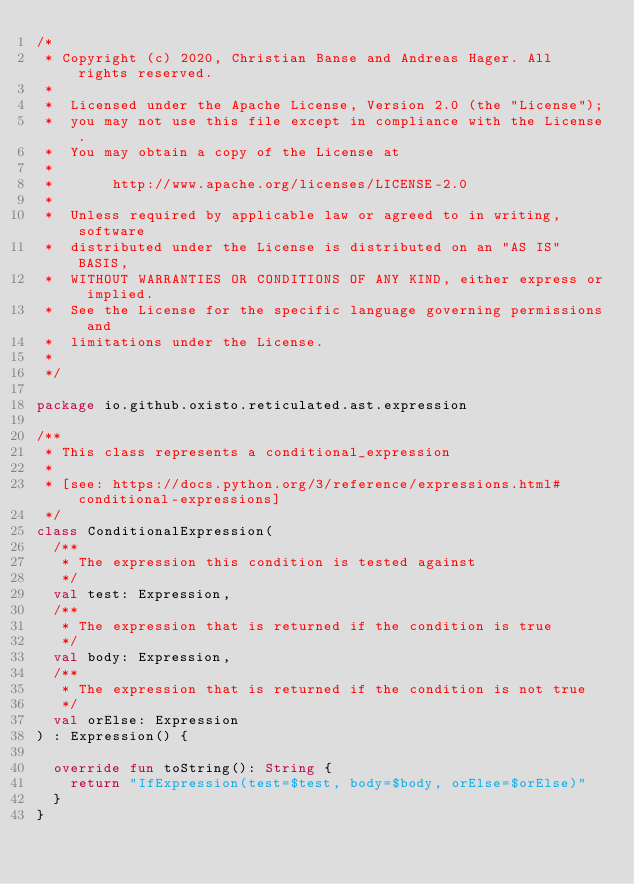<code> <loc_0><loc_0><loc_500><loc_500><_Kotlin_>/*
 * Copyright (c) 2020, Christian Banse and Andreas Hager. All rights reserved.
 *
 *  Licensed under the Apache License, Version 2.0 (the "License");
 *  you may not use this file except in compliance with the License.
 *  You may obtain a copy of the License at
 *
 *       http://www.apache.org/licenses/LICENSE-2.0
 *
 *  Unless required by applicable law or agreed to in writing, software
 *  distributed under the License is distributed on an "AS IS" BASIS,
 *  WITHOUT WARRANTIES OR CONDITIONS OF ANY KIND, either express or implied.
 *  See the License for the specific language governing permissions and
 *  limitations under the License.
 *
 */

package io.github.oxisto.reticulated.ast.expression

/**
 * This class represents a conditional_expression
 *
 * [see: https://docs.python.org/3/reference/expressions.html#conditional-expressions]
 */
class ConditionalExpression(
  /**
   * The expression this condition is tested against
   */
  val test: Expression,
  /**
   * The expression that is returned if the condition is true
   */
  val body: Expression,
  /**
   * The expression that is returned if the condition is not true
   */
  val orElse: Expression
) : Expression() {

  override fun toString(): String {
    return "IfExpression(test=$test, body=$body, orElse=$orElse)"
  }
}
</code> 